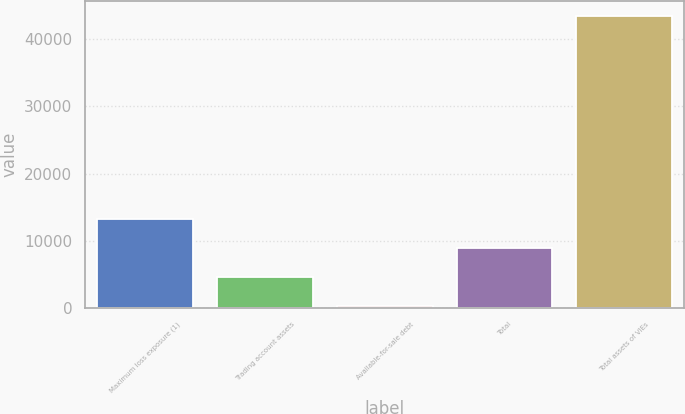<chart> <loc_0><loc_0><loc_500><loc_500><bar_chart><fcel>Maximum loss exposure (1)<fcel>Trading account assets<fcel>Available-for-sale debt<fcel>Total<fcel>Total assets of VIEs<nl><fcel>13279.4<fcel>4651.8<fcel>338<fcel>8965.6<fcel>43476<nl></chart> 